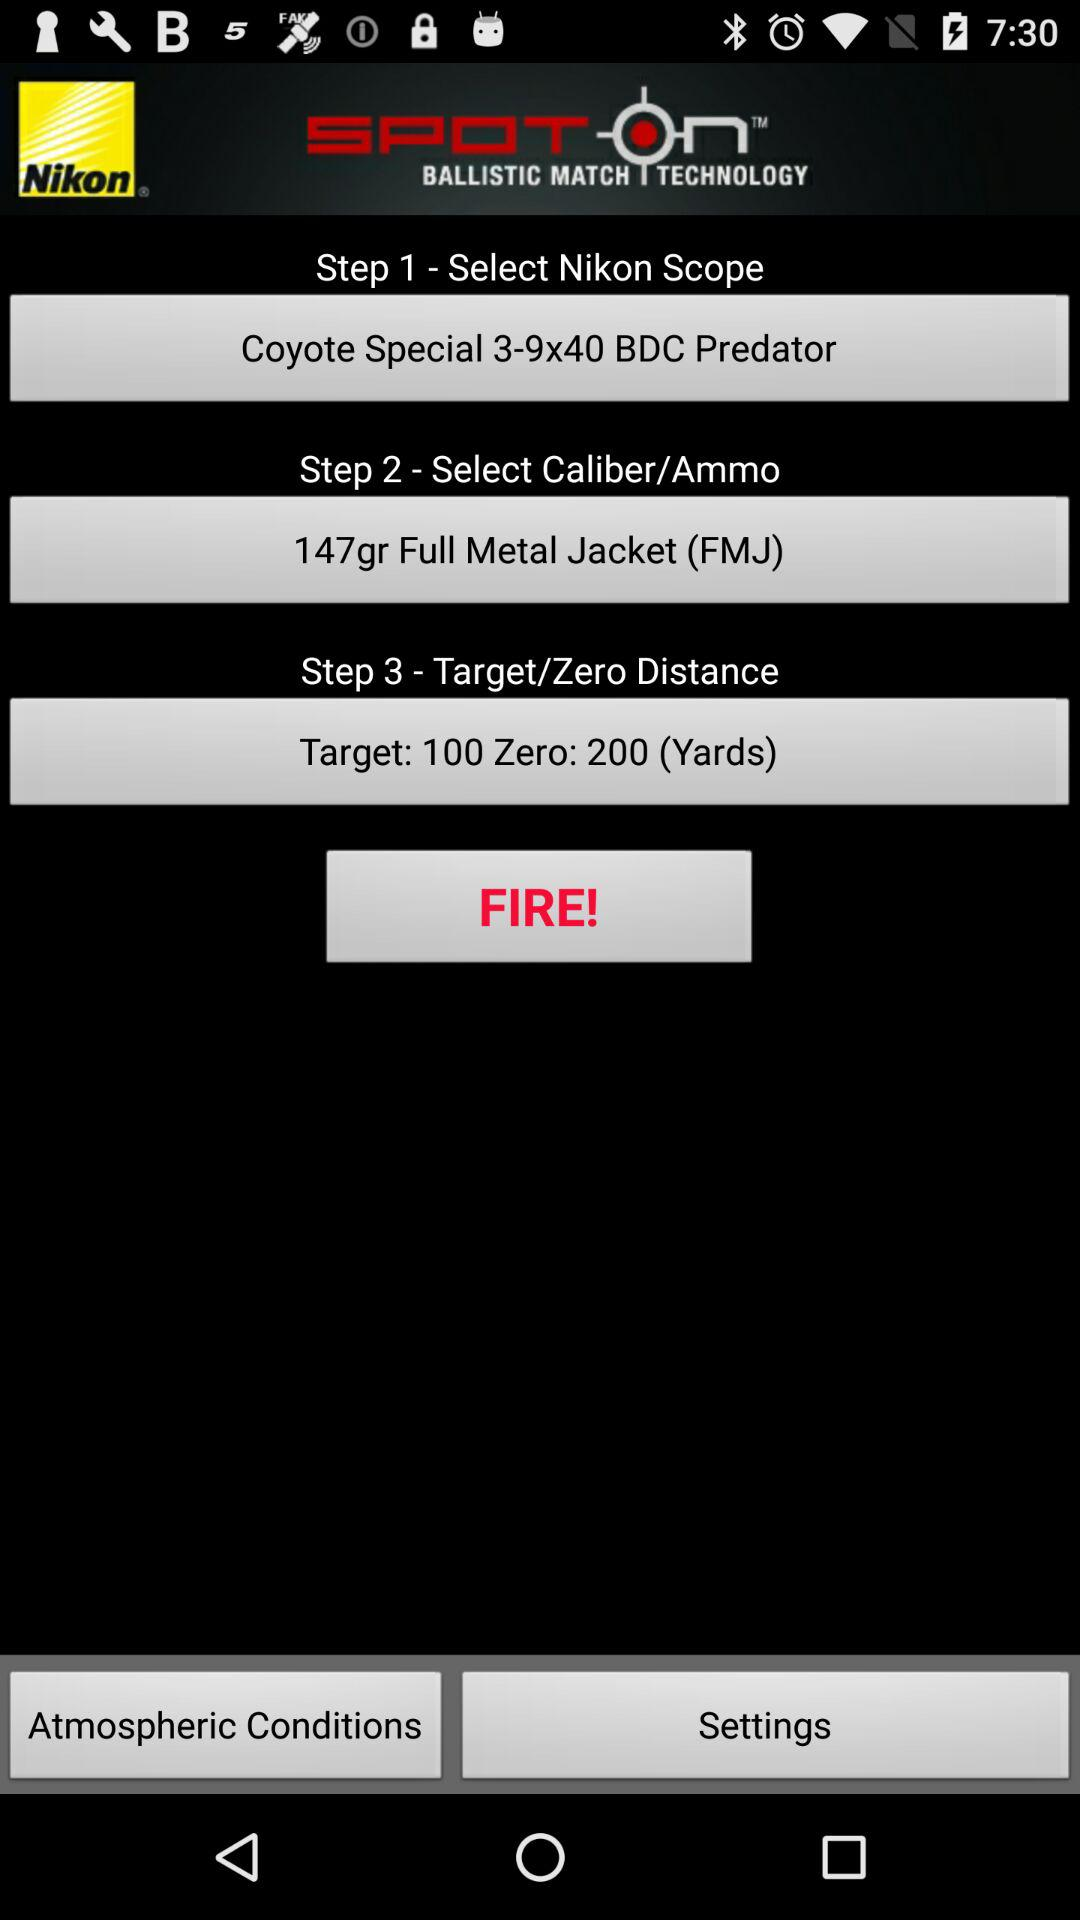What is the application name? The application name is "Nikon SpotOn Ballistic Match". 